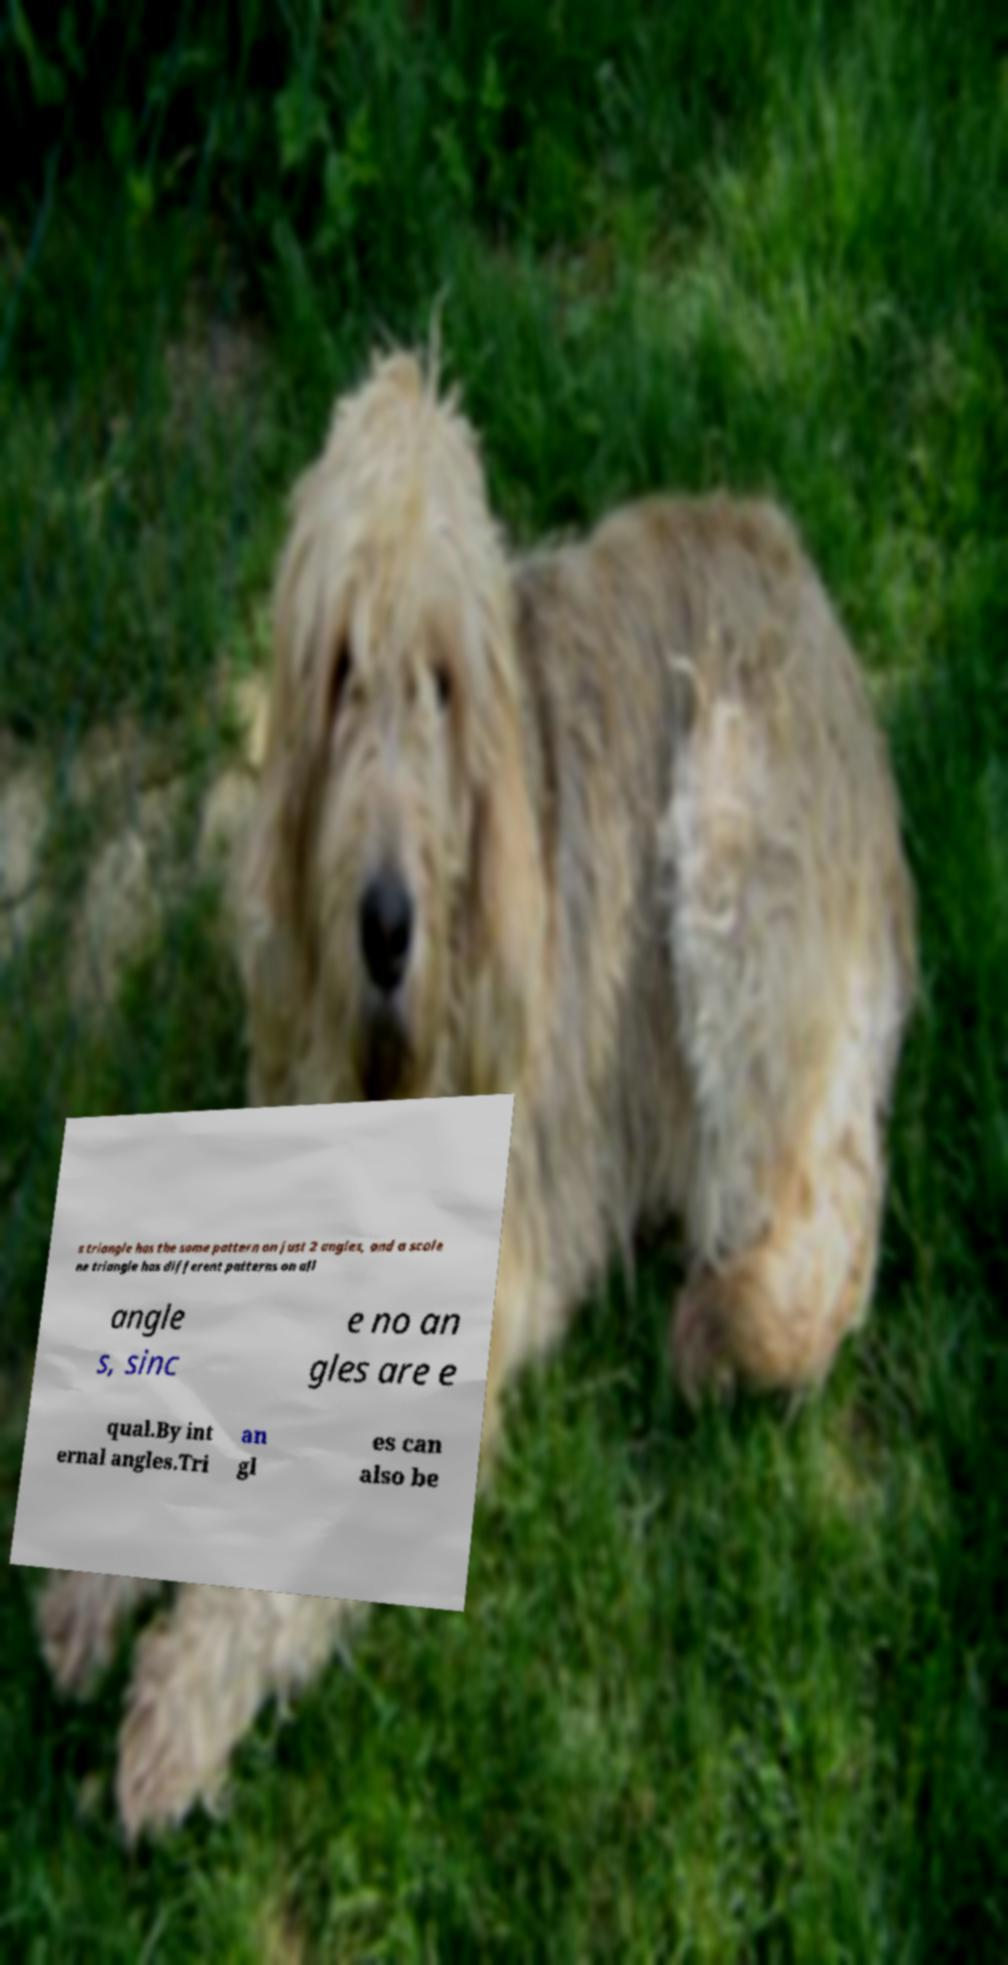There's text embedded in this image that I need extracted. Can you transcribe it verbatim? s triangle has the same pattern on just 2 angles, and a scale ne triangle has different patterns on all angle s, sinc e no an gles are e qual.By int ernal angles.Tri an gl es can also be 